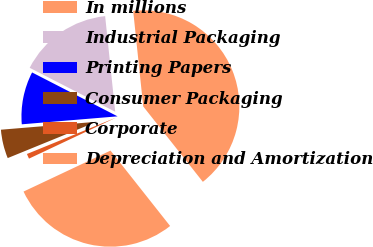Convert chart to OTSL. <chart><loc_0><loc_0><loc_500><loc_500><pie_chart><fcel>In millions<fcel>Industrial Packaging<fcel>Printing Papers<fcel>Consumer Packaging<fcel>Corporate<fcel>Depreciation and Amortization<nl><fcel>41.02%<fcel>15.78%<fcel>8.87%<fcel>4.85%<fcel>0.84%<fcel>28.64%<nl></chart> 